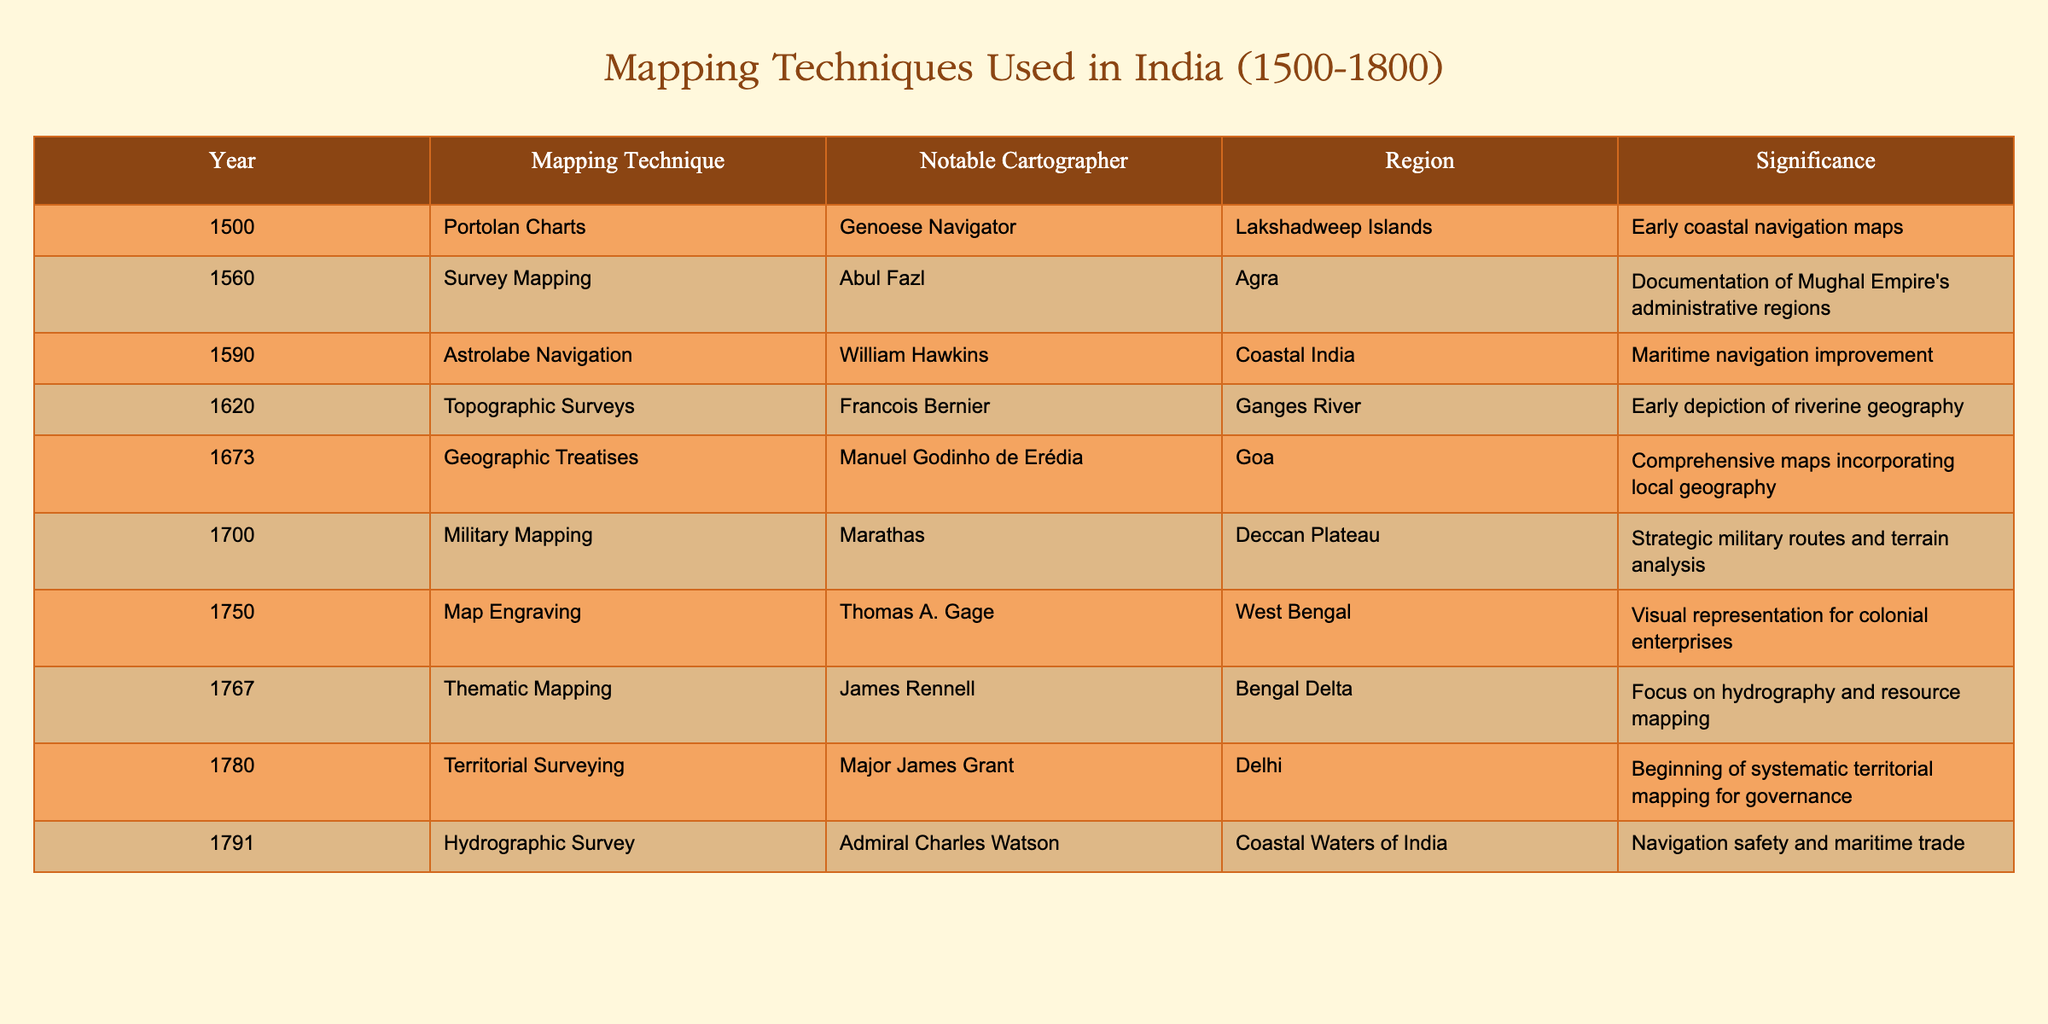What mapping technique was used in 1620? Referring to the table, I can find the row corresponding to the year 1620, where it lists "Topographic Surveys" as the mapping technique.
Answer: Topographic Surveys Who was the notable cartographer for the year 1750? Looking at the table, I see that the notable cartographer for 1750 is Thomas A. Gage, as mentioned in the corresponding row.
Answer: Thomas A. Gage In what region was the "Astrolabe Navigation" technique applied? The table shows that Astrolabe Navigation was used in "Coastal India" in the year 1590, indicating the specific region associated with that technique.
Answer: Coastal India Was "Military Mapping" used before 1700? Checking the years listed in the table, "Military Mapping" is associated with the year 1700, which means it was not used before that year, making this statement false.
Answer: No What is the significance of the mapping technique noted in 1767? From the table, the significance of "Thematic Mapping" in 1767 focuses on hydrography and resource mapping in the Bengal Delta, denoting its importance in that region.
Answer: Hydrography and resource mapping How many unique mapping techniques are listed in the table? By reviewing the table, I can count the unique mapping techniques, which are: Portolan Charts, Survey Mapping, Astrolabe Navigation, Topographic Surveys, Geographic Treatises, Military Mapping, Map Engraving, Thematic Mapping, Territorial Surveying, and Hydrographic Survey. That totals to ten unique techniques.
Answer: 10 What mapping technique has the earliest date in the table? The table indicates that the earliest mapping technique is "Portolan Charts," used in the year 1500, allowing me to identify the date accurately.
Answer: Portolan Charts Which cartographer is linked to the mapping technique that focused on "literature about geography"? The mapping technique related to "Geographic Treatises" is linked to the cartographer Manuel Godinho de Erédia in the year 1673, as per the table.
Answer: Manuel Godinho de Erédia What mapping techniques were used in the Deccan Plateau? Referring to the table, I find that "Military Mapping" is the noted technique used in the Deccan Plateau in the year 1700, thus identifying the relevant technique.
Answer: Military Mapping 